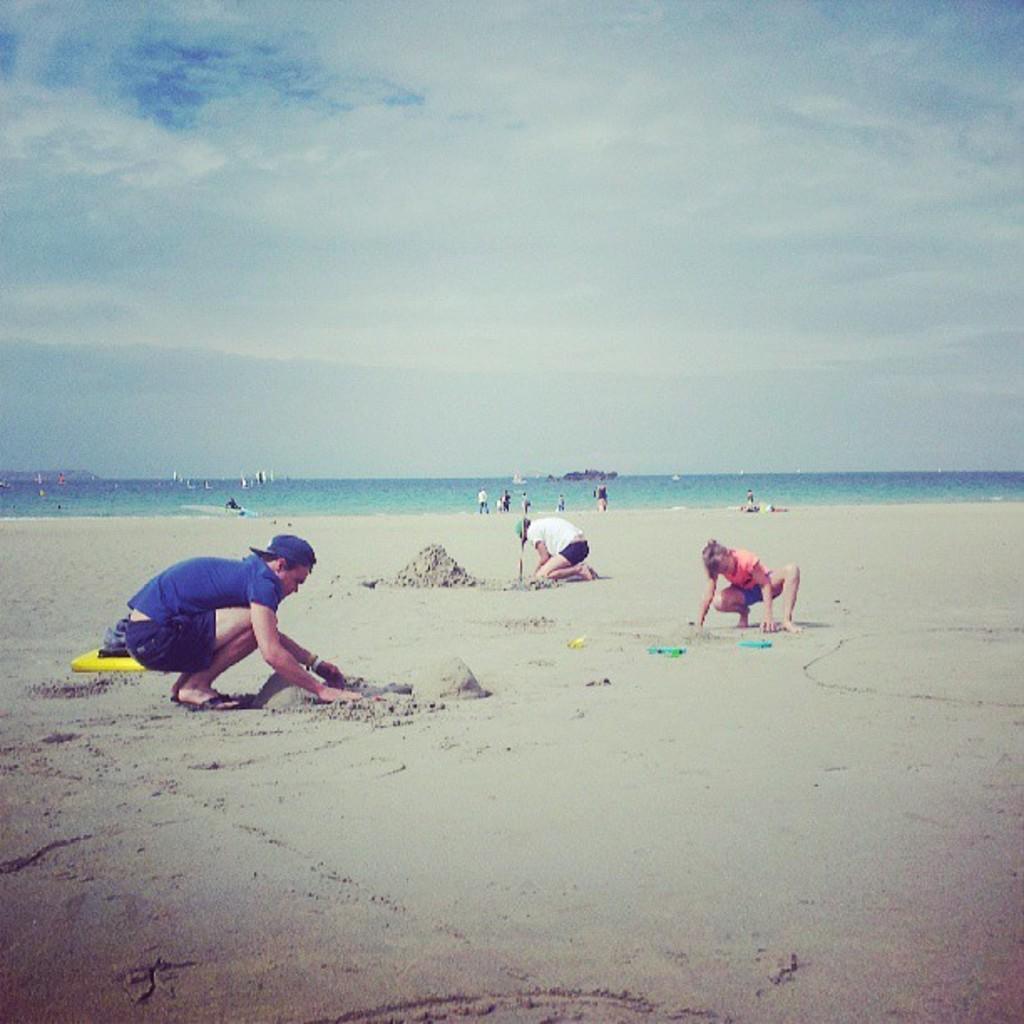In one or two sentences, can you explain what this image depicts? In the image there is a sea and there are three people playing with the sand beside the sea and few people were standing at the sea shore. In the background there is a sky. 